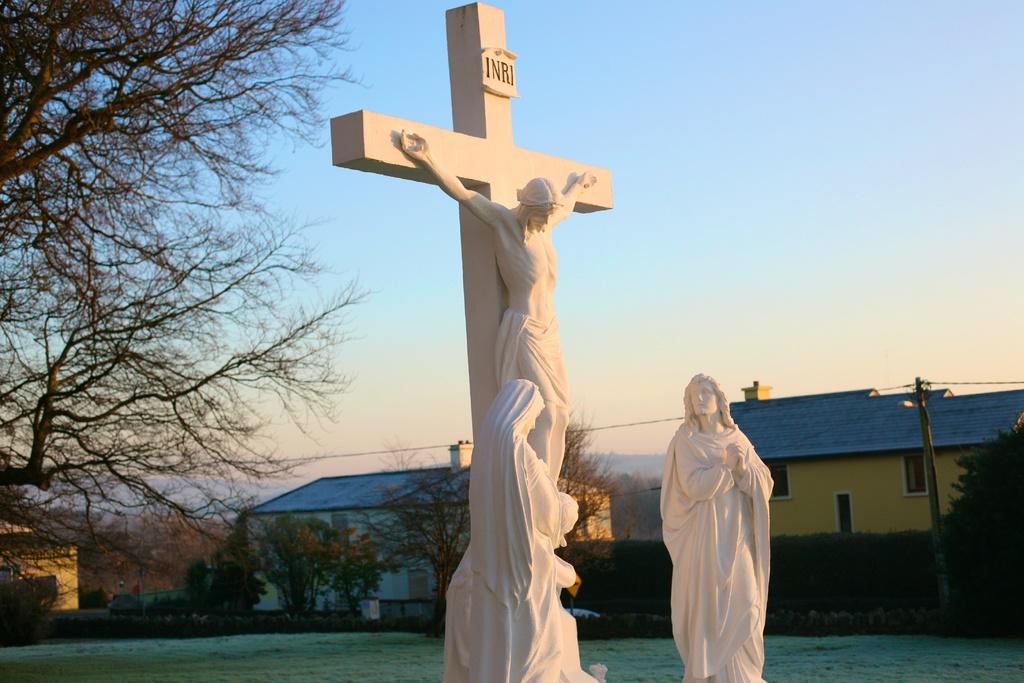What is written on the cross?
Provide a succinct answer. Inri. Which religion does the crucifix represent?
Your response must be concise. Answering does not require reading text in the image. 